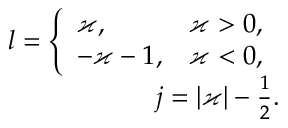<formula> <loc_0><loc_0><loc_500><loc_500>\begin{array} { r } { l = \left \{ \begin{array} { l l } { \varkappa , } & { \varkappa > 0 , } \\ { - \varkappa - 1 , } & { \varkappa < 0 , } \end{array} } \\ { j = | \varkappa | - \frac { 1 } { 2 } . } \end{array}</formula> 